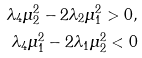<formula> <loc_0><loc_0><loc_500><loc_500>\lambda _ { 4 } \mu _ { 2 } ^ { 2 } - 2 \lambda _ { 2 } \mu _ { 1 } ^ { 2 } > 0 , \\ \lambda _ { 4 } \mu _ { 1 } ^ { 2 } - 2 \lambda _ { 1 } \mu _ { 2 } ^ { 2 } < 0</formula> 